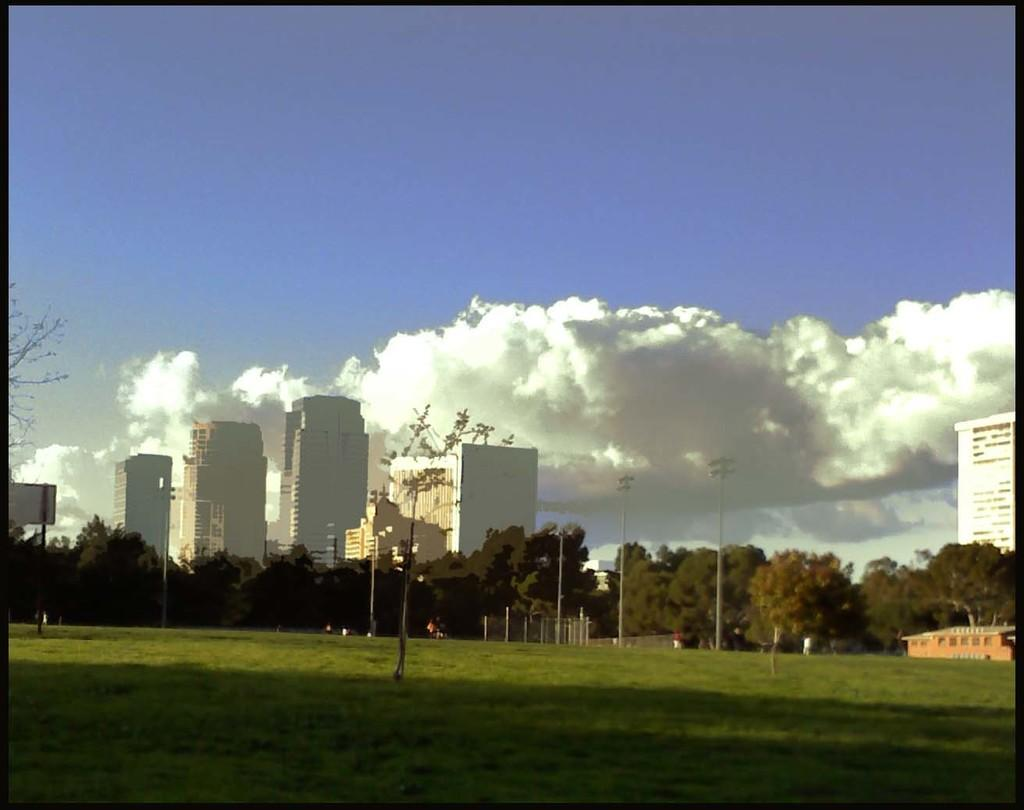What type of vegetation can be seen in the image? There is grass in the image. What other natural elements are present in the image? There are trees in the image. What man-made structures can be seen in the image? There are buildings in the image. Are there any specific objects related to infrastructure in the image? Yes, there are poles in the image. Can you describe a specific pole in the image? There is a pole with a board in the image. What can be seen in the background of the image? The sky is visible in the background of the image, and there are clouds in the sky. What type of feast is being prepared in the image? There is no indication of a feast or any food preparation in the image. What team is responsible for maintaining the poles in the image? There is no information about a team or any maintenance activity related to the poles in the image. 